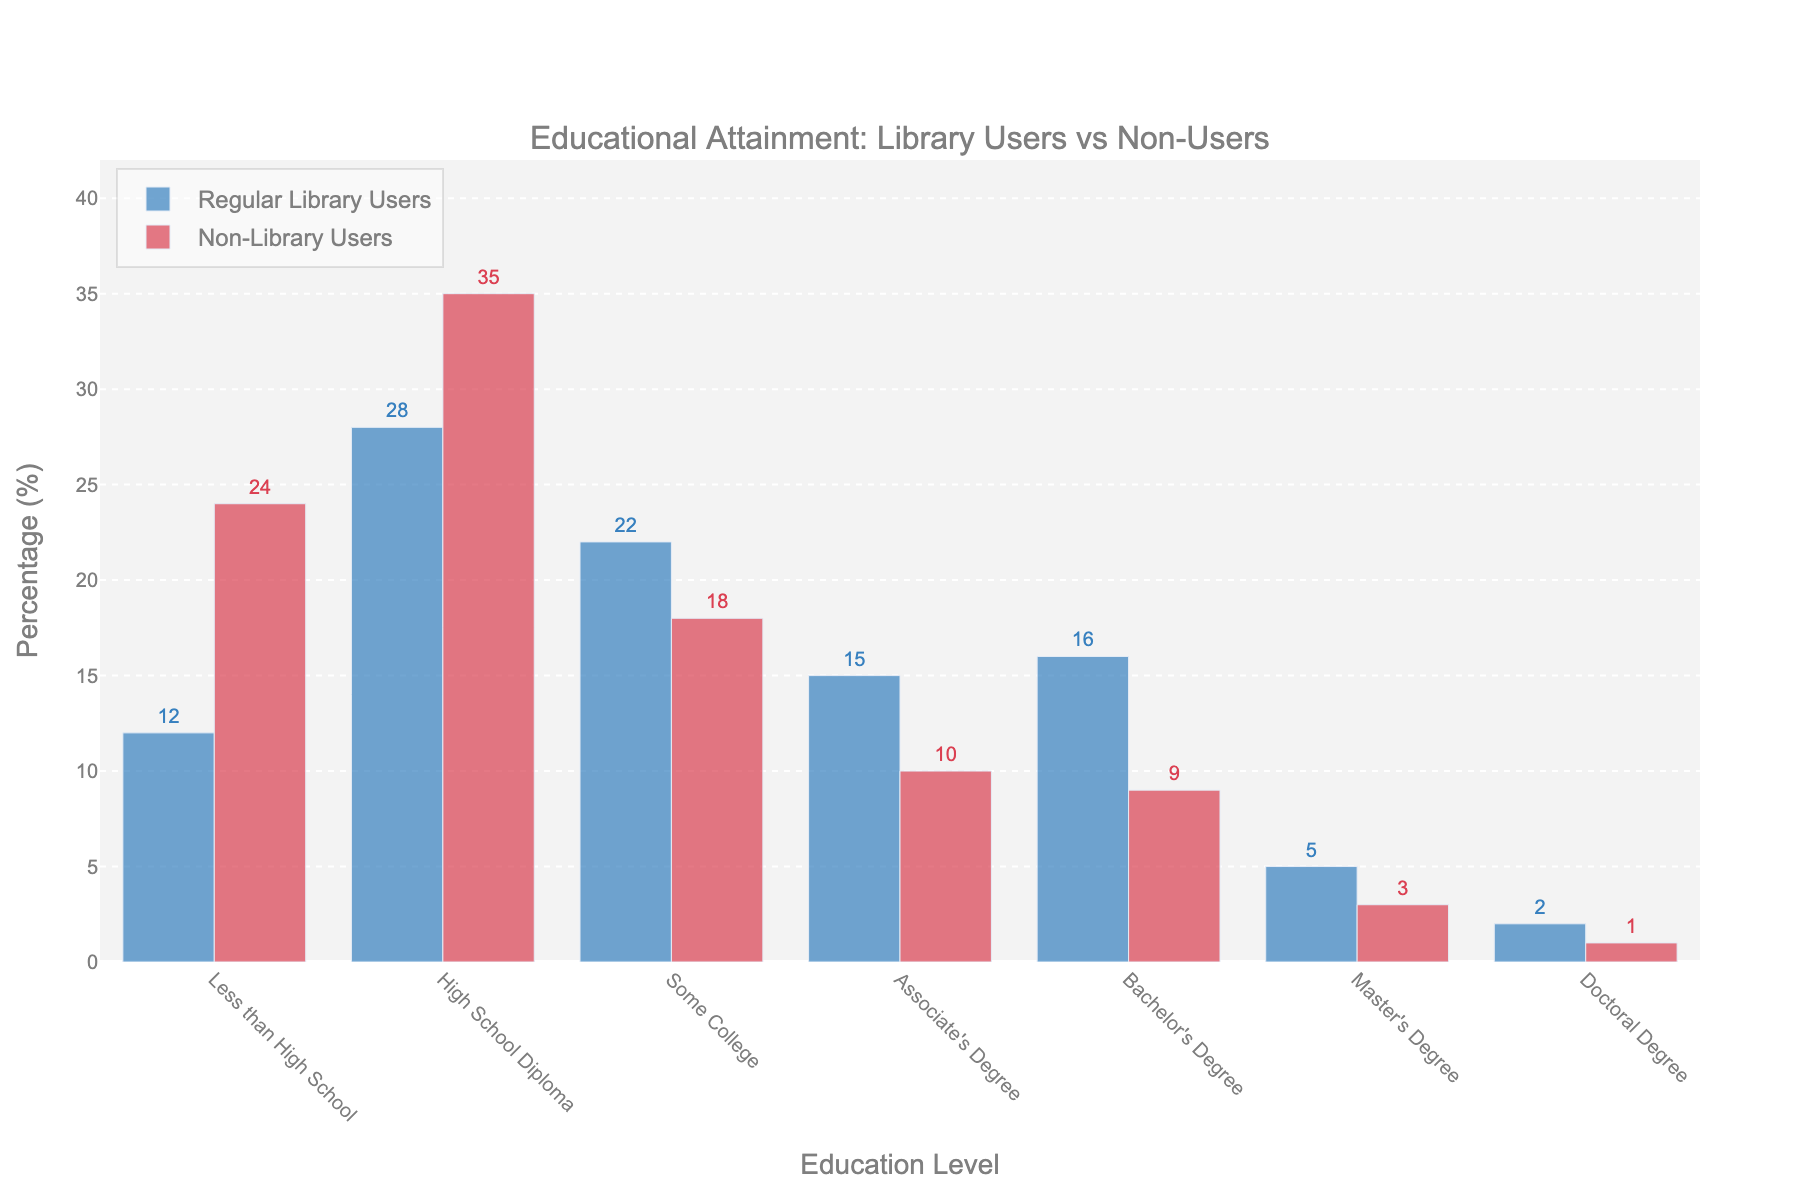Which education level has the highest percentage of regular library users? By examining the heights of the bars for regular library users in the chart, the highest bar corresponds to those with a high school diploma at 28%.
Answer: High School Diploma How does the percentage of non-library users with less than a high school diploma compare to those with a bachelor's degree? By comparing the heights of the bars for non-library users, the bar for less than high school is 24%, and the bar for a bachelor's degree is 9%. 24% is greater than 9%.
Answer: Less than High School is greater What is the total percentage of regular library users with an associate's degree or bachelor's degree? Add the percentages of regular library users with an associate's degree (15%) and bachelor's degree (16%). 15% + 16% equals 31%.
Answer: 31% Among regular library users, what is the difference in percentage between those with some college and those with a high school diploma? Find the difference between the percentages of regular library users with some college (22%) and those with a high school diploma (28%). 28% - 22% = 6%.
Answer: 6% Which group has a higher percentage of people with a doctoral degree, regular library users or non-library users? By looking at the heights of the bars representing doctoral degrees, regular library users have 2%, and non-library users have 1%. 2% is greater than 1%.
Answer: Regular Library Users What is the combined percentage of non-library users with a high school diploma and some college education? Add the percentages of non-library users with a high school diploma (35%) and some college (18%). 35% + 18% equals 53%.
Answer: 53% What is the average percentage of regular library users across all education levels? Sum all percentages of regular library users (12% + 28% + 22% + 15% + 16% + 5% + 2%) and divide by the number of levels (7). (12 + 28 + 22 + 15 + 16 + 5 + 2) / 7 ≈ 14.29%.
Answer: 14.29% Which group of non-library users has the lowest percentage representation, and what is that percentage? By examining the heights of the bars for non-library users, the lowest bar corresponds to those with a doctoral degree at 1%.
Answer: Doctoral Degree Is the percentage of regular library users with less than a high school diploma greater than, less than, or equal to the percentage of non-library users with some college? Compare the percentages: regular library users with less than high school (12%) and non-library users with some college (18%). 12% is less than 18%.
Answer: Less Than 